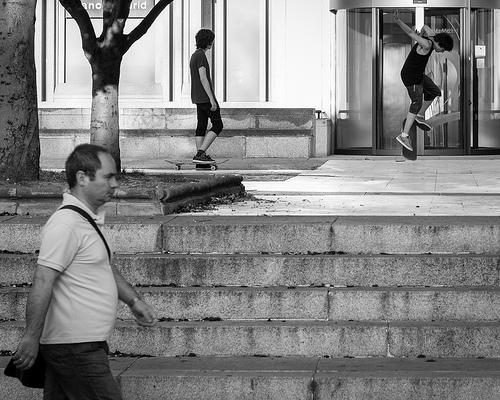Question: who has a bag over shoulder?
Choices:
A. Woman shopping.
B. Middle aged man walking on sidewalk.
C. Kid at bus stop.
D. Girl walking in hall.
Answer with the letter. Answer: B Question: what is behind boys in picture?
Choices:
A. Parents.
B. Building with glass doors.
C. Girls.
D. Wall.
Answer with the letter. Answer: B Question: what is between man and boys?
Choices:
A. Tent.
B. Creek.
C. Bear.
D. Trees.
Answer with the letter. Answer: D Question: what is next to sidewalk?
Choices:
A. Crossing guard.
B. Street signs.
C. Bike.
D. Cement stairs.
Answer with the letter. Answer: D Question: where is trash can?
Choices:
A. Left side of doors.
B. Outside.
C. Under sink.
D. In kitchen.
Answer with the letter. Answer: A 